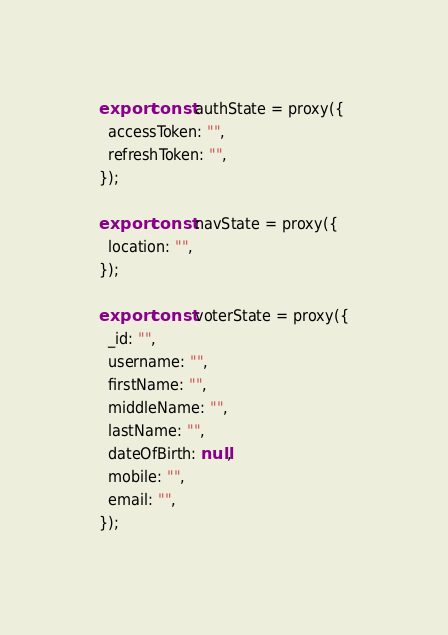Convert code to text. <code><loc_0><loc_0><loc_500><loc_500><_JavaScript_>
export const authState = proxy({
  accessToken: "",
  refreshToken: "",
});

export const navState = proxy({
  location: "",
});

export const voterState = proxy({
  _id: "",
  username: "",
  firstName: "",
  middleName: "",
  lastName: "",
  dateOfBirth: null,
  mobile: "",
  email: "",
});
</code> 